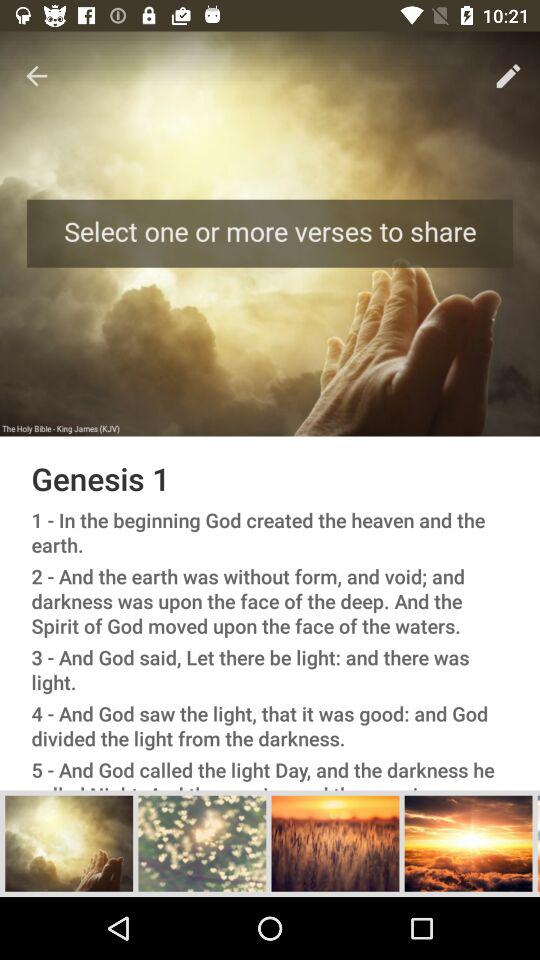How many verses are in the chapter?
Answer the question using a single word or phrase. 5 